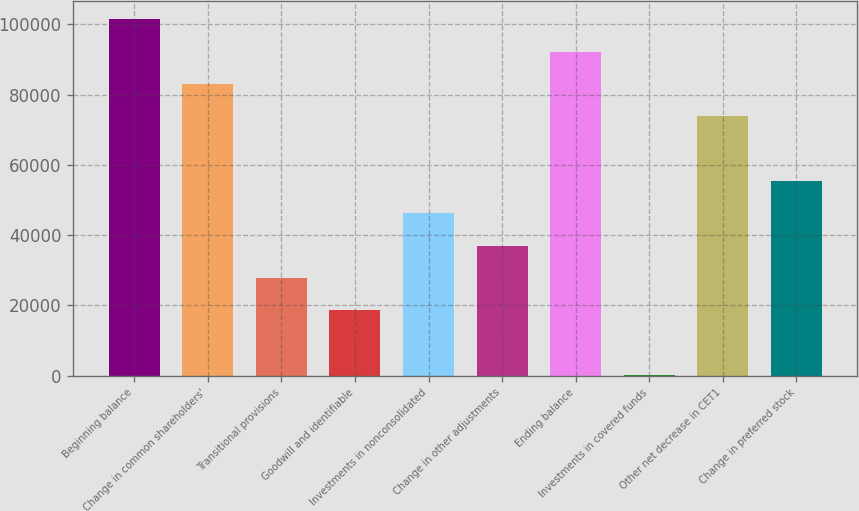Convert chart. <chart><loc_0><loc_0><loc_500><loc_500><bar_chart><fcel>Beginning balance<fcel>Change in common shareholders'<fcel>Transitional provisions<fcel>Goodwill and identifiable<fcel>Investments in nonconsolidated<fcel>Change in other adjustments<fcel>Ending balance<fcel>Investments in covered funds<fcel>Other net decrease in CET1<fcel>Change in preferred stock<nl><fcel>101438<fcel>83021.5<fcel>27770.5<fcel>18562<fcel>46187.5<fcel>36979<fcel>92230<fcel>145<fcel>73813<fcel>55396<nl></chart> 